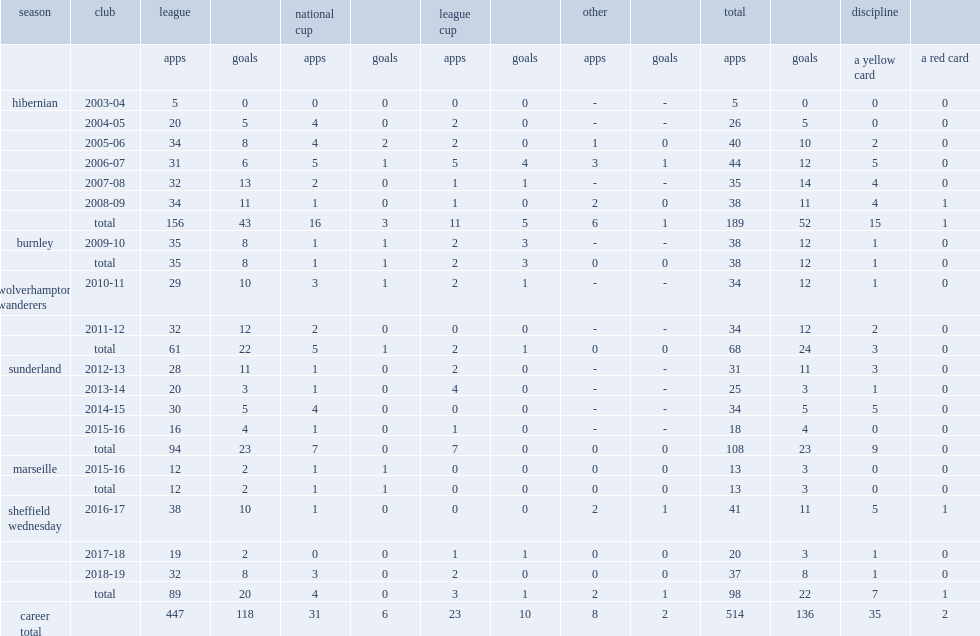Fletcher began his club career with hibernian, how many league games did he play? 156.0. Fletcher began his club career with hibernian, how many goals did he score? 43.0. 